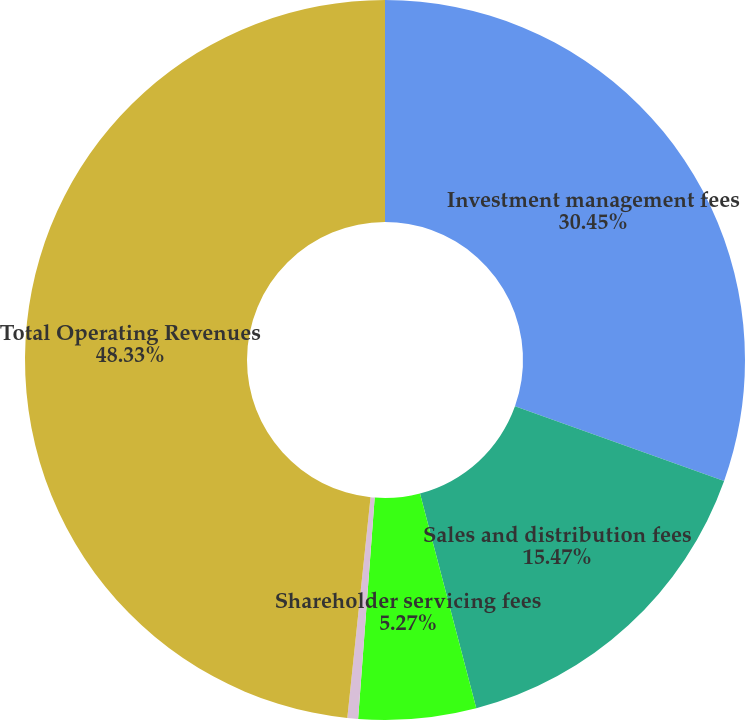Convert chart to OTSL. <chart><loc_0><loc_0><loc_500><loc_500><pie_chart><fcel>Investment management fees<fcel>Sales and distribution fees<fcel>Shareholder servicing fees<fcel>Other net<fcel>Total Operating Revenues<nl><fcel>30.45%<fcel>15.47%<fcel>5.27%<fcel>0.48%<fcel>48.33%<nl></chart> 